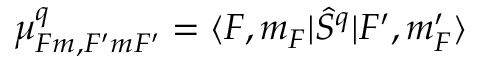Convert formula to latex. <formula><loc_0><loc_0><loc_500><loc_500>\mu _ { F m , F ^ { \prime } m F ^ { \prime } } ^ { q } = \langle F , m _ { F } | \hat { S } ^ { q } | F ^ { \prime } , m _ { F } ^ { \prime } \rangle</formula> 